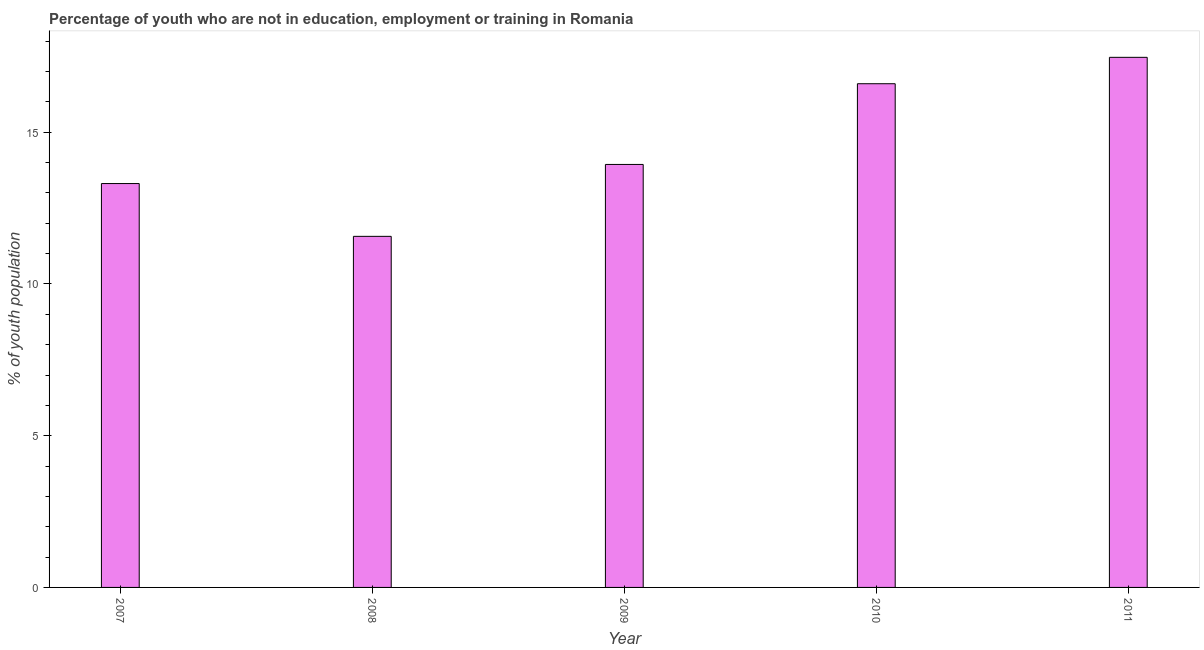What is the title of the graph?
Provide a succinct answer. Percentage of youth who are not in education, employment or training in Romania. What is the label or title of the Y-axis?
Your response must be concise. % of youth population. What is the unemployed youth population in 2007?
Offer a terse response. 13.31. Across all years, what is the maximum unemployed youth population?
Offer a very short reply. 17.47. Across all years, what is the minimum unemployed youth population?
Keep it short and to the point. 11.57. In which year was the unemployed youth population minimum?
Keep it short and to the point. 2008. What is the sum of the unemployed youth population?
Provide a succinct answer. 72.89. What is the difference between the unemployed youth population in 2007 and 2010?
Offer a terse response. -3.29. What is the average unemployed youth population per year?
Your answer should be very brief. 14.58. What is the median unemployed youth population?
Offer a very short reply. 13.94. Do a majority of the years between 2008 and 2007 (inclusive) have unemployed youth population greater than 14 %?
Provide a succinct answer. No. What is the ratio of the unemployed youth population in 2007 to that in 2010?
Offer a very short reply. 0.8. Is the unemployed youth population in 2008 less than that in 2011?
Provide a succinct answer. Yes. What is the difference between the highest and the second highest unemployed youth population?
Keep it short and to the point. 0.87. Is the sum of the unemployed youth population in 2007 and 2008 greater than the maximum unemployed youth population across all years?
Offer a very short reply. Yes. What is the difference between the highest and the lowest unemployed youth population?
Give a very brief answer. 5.9. How many bars are there?
Provide a succinct answer. 5. Are all the bars in the graph horizontal?
Provide a succinct answer. No. What is the % of youth population of 2007?
Give a very brief answer. 13.31. What is the % of youth population of 2008?
Ensure brevity in your answer.  11.57. What is the % of youth population in 2009?
Provide a succinct answer. 13.94. What is the % of youth population in 2010?
Keep it short and to the point. 16.6. What is the % of youth population of 2011?
Your response must be concise. 17.47. What is the difference between the % of youth population in 2007 and 2008?
Offer a very short reply. 1.74. What is the difference between the % of youth population in 2007 and 2009?
Your response must be concise. -0.63. What is the difference between the % of youth population in 2007 and 2010?
Provide a succinct answer. -3.29. What is the difference between the % of youth population in 2007 and 2011?
Your answer should be very brief. -4.16. What is the difference between the % of youth population in 2008 and 2009?
Keep it short and to the point. -2.37. What is the difference between the % of youth population in 2008 and 2010?
Provide a short and direct response. -5.03. What is the difference between the % of youth population in 2009 and 2010?
Provide a succinct answer. -2.66. What is the difference between the % of youth population in 2009 and 2011?
Keep it short and to the point. -3.53. What is the difference between the % of youth population in 2010 and 2011?
Offer a very short reply. -0.87. What is the ratio of the % of youth population in 2007 to that in 2008?
Your answer should be compact. 1.15. What is the ratio of the % of youth population in 2007 to that in 2009?
Your answer should be compact. 0.95. What is the ratio of the % of youth population in 2007 to that in 2010?
Your response must be concise. 0.8. What is the ratio of the % of youth population in 2007 to that in 2011?
Keep it short and to the point. 0.76. What is the ratio of the % of youth population in 2008 to that in 2009?
Offer a terse response. 0.83. What is the ratio of the % of youth population in 2008 to that in 2010?
Provide a succinct answer. 0.7. What is the ratio of the % of youth population in 2008 to that in 2011?
Ensure brevity in your answer.  0.66. What is the ratio of the % of youth population in 2009 to that in 2010?
Provide a short and direct response. 0.84. What is the ratio of the % of youth population in 2009 to that in 2011?
Offer a very short reply. 0.8. What is the ratio of the % of youth population in 2010 to that in 2011?
Make the answer very short. 0.95. 